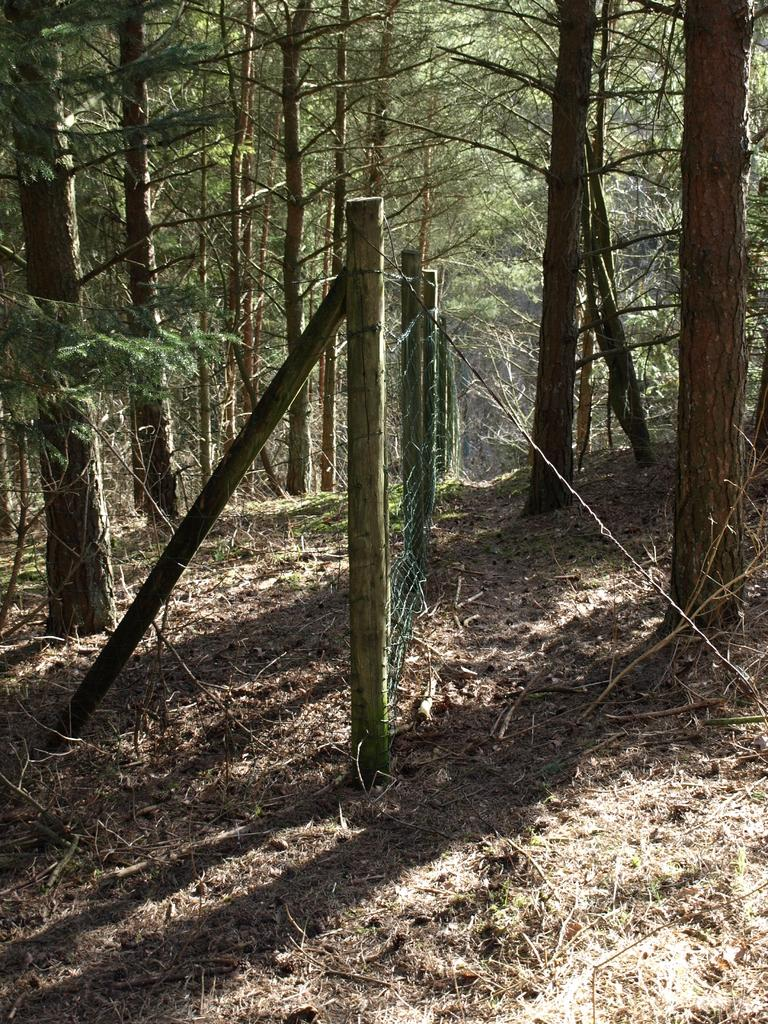What type of vegetation can be seen in the image? There are trees in the image. What can be found on the ground in the image? There are twigs on the ground in the image. What does the father's tongue look like in the image? There is no father or tongue present in the image. 